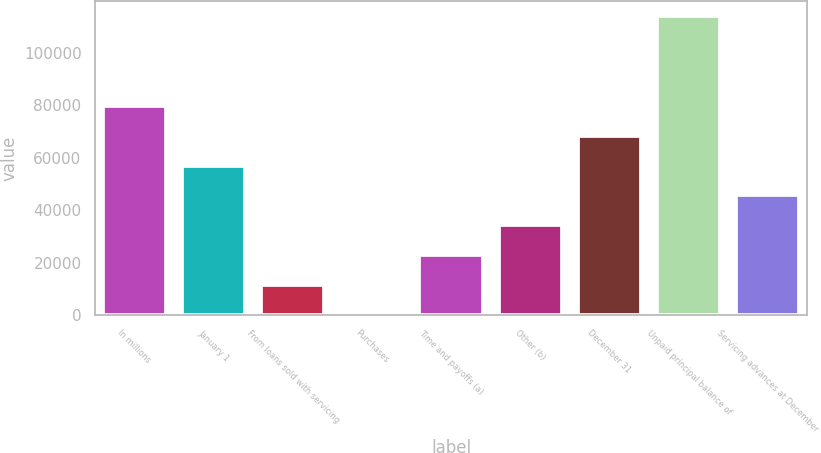Convert chart. <chart><loc_0><loc_0><loc_500><loc_500><bar_chart><fcel>In millions<fcel>January 1<fcel>From loans sold with servicing<fcel>Purchases<fcel>Time and payoffs (a)<fcel>Other (b)<fcel>December 31<fcel>Unpaid principal balance of<fcel>Servicing advances at December<nl><fcel>79828.8<fcel>57052<fcel>11498.4<fcel>110<fcel>22886.8<fcel>34275.2<fcel>68440.4<fcel>113994<fcel>45663.6<nl></chart> 